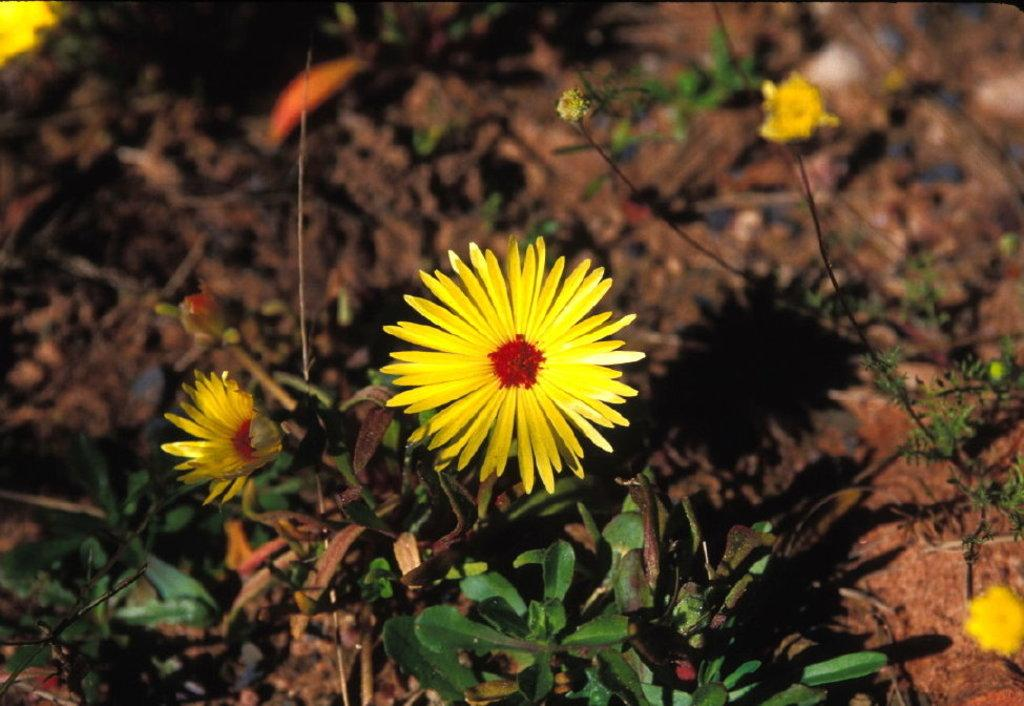What type of living organisms are in the image? There are plants in the image. What color are the flowers on the plants? The flowers on the plants are yellow. Where are the plants located in the image? The plants are on the ground. What else can be seen on the ground in the image? There are objects on the ground. Is the queen present in the image, sitting on a balloon? No, there is no queen or balloon present in the image. The image features plants with yellow flowers on the ground, along with other objects. 